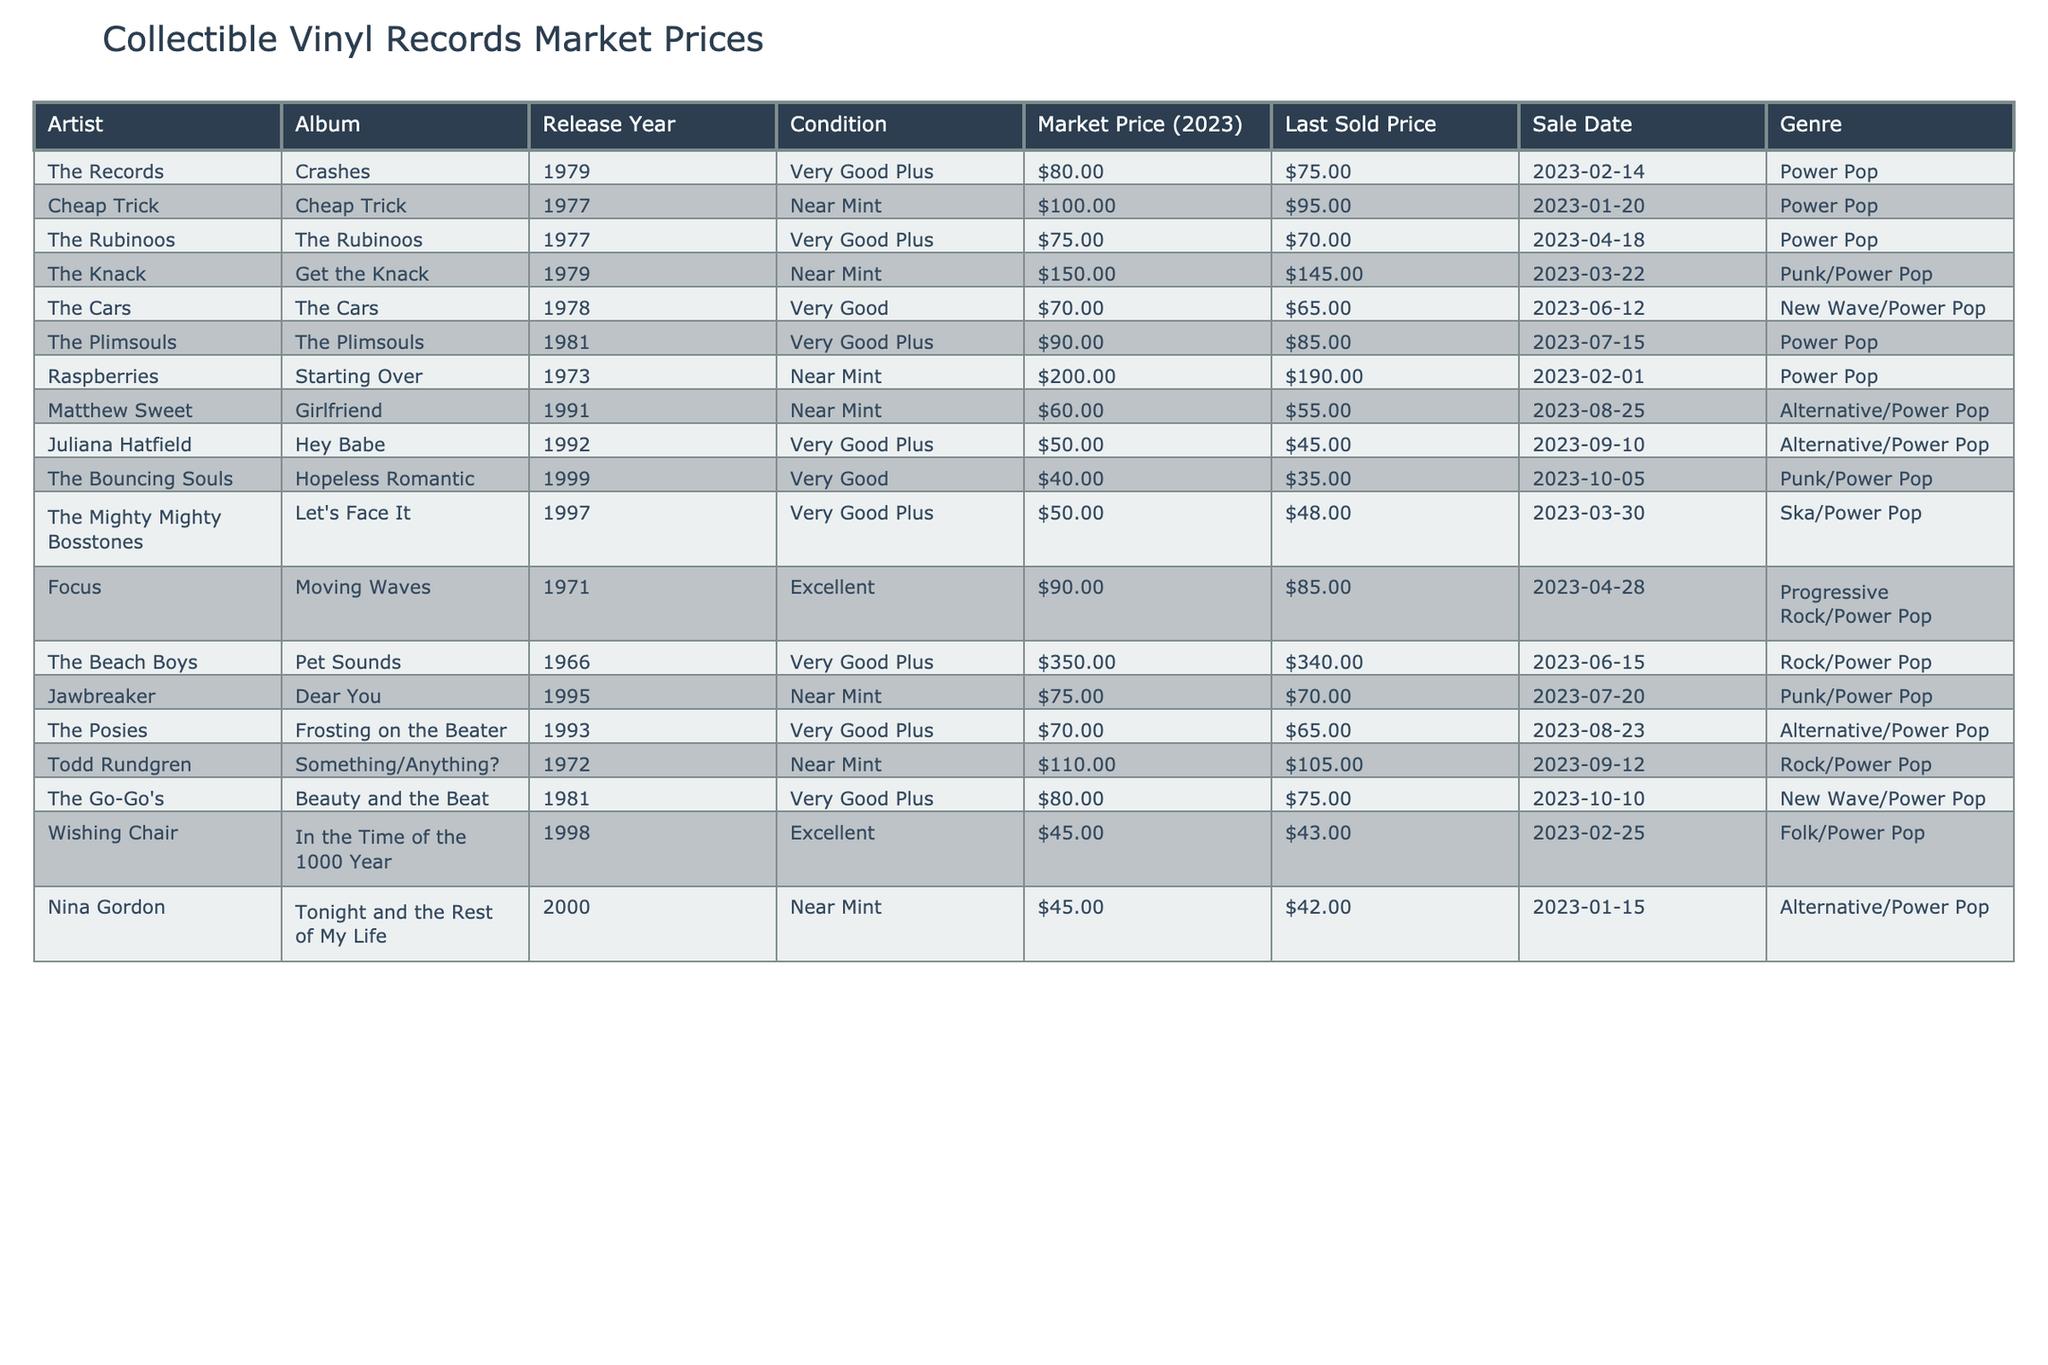What is the Market Price of "Raspberries - Starting Over"? The table shows that the Market Price of the album "Starting Over" by Raspberries is listed as $200.00.
Answer: $200.00 Which artist has the highest Market Price? Looking at the Market Prices in the table, "The Beach Boys - Pet Sounds" has the highest price at $350.00.
Answer: The Beach Boys What is the average Market Price of all the records listed? To find the average, sum all Market Prices: $80 + $100 + $75 + $150 + $70 + $90 + $200 + $60 + $50 + $40 + $50 + $90 + $350 + $75 + $70 + $110 + $80 + $45 + $45 = $1,700. There are 19 records, so the average is $1,700 / 19 ≈ $89.47.
Answer: Approximately $89.47 Did any record sold for more than $200 in the last sale? The table shows "Raspberries - Starting Over" was sold for $190.00, which is less than $200. Therefore, no records sold for more than $200.
Answer: No What is the difference between the highest and lowest Market Price? The highest Market Price is $350.00 ("The Beach Boys"), and the lowest is $40.00 ("The Bouncing Souls"). The difference is $350.00 - $40.00 = $310.00.
Answer: $310.00 How many records have a condition listed as "Near Mint"? By counting the entries, I can see there are 7 records listed with the condition "Near Mint".
Answer: 7 Which genre has the most records in the table? There are 8 records categorized as "Power Pop" in the table, making it the genre with the most entries.
Answer: Power Pop What is the total selling price of all records that were sold on or after January 1, 2023? The total selling prices are: $75 (The Records) + $95 (Cheap Trick) + $70 (The Rubinoos) + $145 (The Knack) + $65 (The Cars) + $85 (The Plimsouls) + $190 (Raspberries) + $55 (Matthew Sweet) + $45 (Juliana Hatfield) + $35 (The Bouncing Souls) + $48 (The Mighty Mighty Bosstones) + $85 (Focus) + $340 (The Beach Boys) + $70 (Jawbreaker) + $65 (The Posies) + $105 (Todd Rundgren) + $75 (The Go-Go's) + $43 (Wishing Chair) + $42 (Nina Gordon) = $1,281.
Answer: $1,281 What is the last sold price of "Cheap Trick - Cheap Trick"? The table indicates that "Cheap Trick - Cheap Trick" had a last sold price of $95.00.
Answer: $95.00 Which album had the most recent sale date? The most recent sale date in the table is "The Bouncing Souls - Hopeless Romantic," sold on 2023-10-05.
Answer: The Bouncing Souls - Hopeless Romantic 